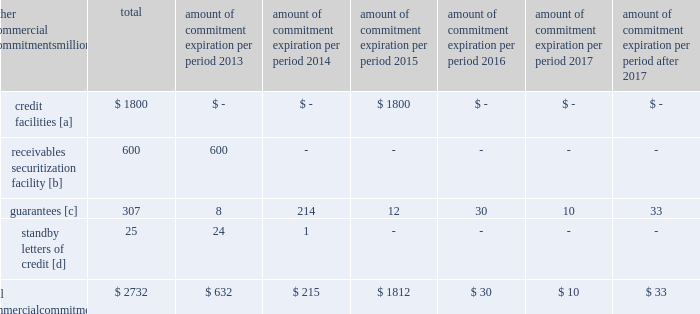Amount of commitment expiration per period other commercial commitments after millions total 2013 2014 2015 2016 2017 2017 .
[a] none of the credit facility was used as of december 31 , 2012 .
[b] $ 100 million of the receivables securitization facility was utilized at december 31 , 2012 , which is accounted for as debt .
The full program matures in july 2013 .
[c] includes guaranteed obligations related to our headquarters building , equipment financings , and affiliated operations .
[d] none of the letters of credit were drawn upon as of december 31 , 2012 .
Off-balance sheet arrangements guarantees 2013 at december 31 , 2012 , we were contingently liable for $ 307 million in guarantees .
We have recorded a liability of $ 2 million for the fair value of these obligations as of december 31 , 2012 and 2011 .
We entered into these contingent guarantees in the normal course of business , and they include guaranteed obligations related to our headquarters building , equipment financings , and affiliated operations .
The final guarantee expires in 2022 .
We are not aware of any existing event of default that would require us to satisfy these guarantees .
We do not expect that these guarantees will have a material adverse effect on our consolidated financial condition , results of operations , or liquidity .
Other matters labor agreements 2013 approximately 86% ( 86 % ) of our 45928 full-time-equivalent employees are represented by 14 major rail unions .
During the year , we concluded the most recent round of negotiations , which began in 2010 , with the ratification of new agreements by several unions that continued negotiating into 2012 .
All of the unions executed similar multi-year agreements that provide for higher employee cost sharing of employee health and welfare benefits and higher wages .
The current agreements will remain in effect until renegotiated under provisions of the railway labor act .
The next round of negotiations will begin in early 2015 .
Inflation 2013 long periods of inflation significantly increase asset replacement costs for capital-intensive companies .
As a result , assuming that we replace all operating assets at current price levels , depreciation charges ( on an inflation-adjusted basis ) would be substantially greater than historically reported amounts .
Derivative financial instruments 2013 we may use derivative financial instruments in limited instances to assist in managing our overall exposure to fluctuations in interest rates and fuel prices .
We are not a party to leveraged derivatives and , by policy , do not use derivative financial instruments for speculative purposes .
Derivative financial instruments qualifying for hedge accounting must maintain a specified level of effectiveness between the hedging instrument and the item being hedged , both at inception and throughout the hedged period .
We formally document the nature and relationships between the hedging instruments and hedged items at inception , as well as our risk-management objectives , strategies for undertaking the various hedge transactions , and method of assessing hedge effectiveness .
Changes in the fair market value of derivative financial instruments that do not qualify for hedge accounting are charged to earnings .
We may use swaps , collars , futures , and/or forward contracts to mitigate the risk of adverse movements in interest rates and fuel prices ; however , the use of these derivative financial instruments may limit future benefits from favorable price movements .
Market and credit risk 2013 we address market risk related to derivative financial instruments by selecting instruments with value fluctuations that highly correlate with the underlying hedged item .
We manage credit risk related to derivative financial instruments , which is minimal , by requiring high credit standards for counterparties and periodic settlements .
At december 31 , 2012 and 2011 , we were not required to provide collateral , nor had we received collateral , relating to our hedging activities. .
Without the receivables securitization facility in 2012 , what would total commitments have been , in millions?\\n? 
Computations: (2732 - 100)
Answer: 2632.0. 